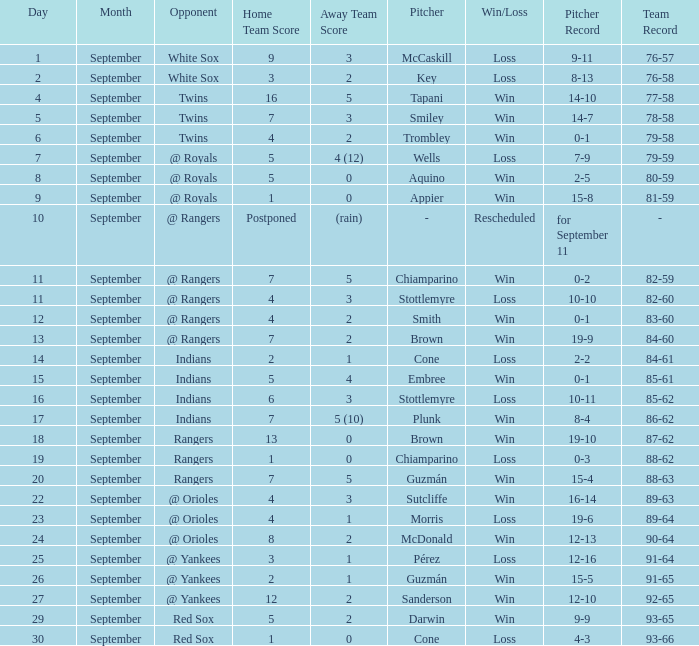What opponent has a record of 86-62? Indians. 